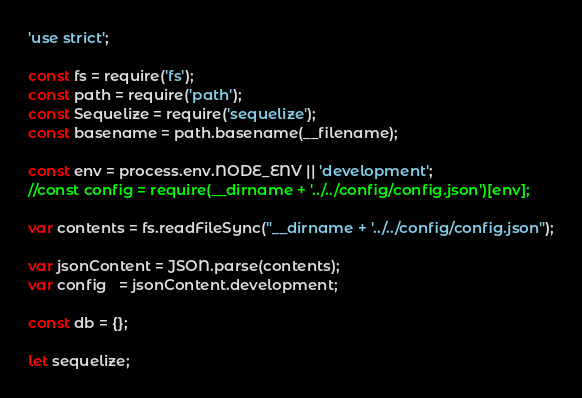<code> <loc_0><loc_0><loc_500><loc_500><_JavaScript_>'use strict';

const fs = require('fs');
const path = require('path');
const Sequelize = require('sequelize');
const basename = path.basename(__filename);

const env = process.env.NODE_ENV || 'development';
//const config = require(__dirname + '../../config/config.json')[env];

var contents = fs.readFileSync("__dirname + '../../config/config.json");

var jsonContent = JSON.parse(contents);
var config   = jsonContent.development;

const db = {};

let sequelize;</code> 